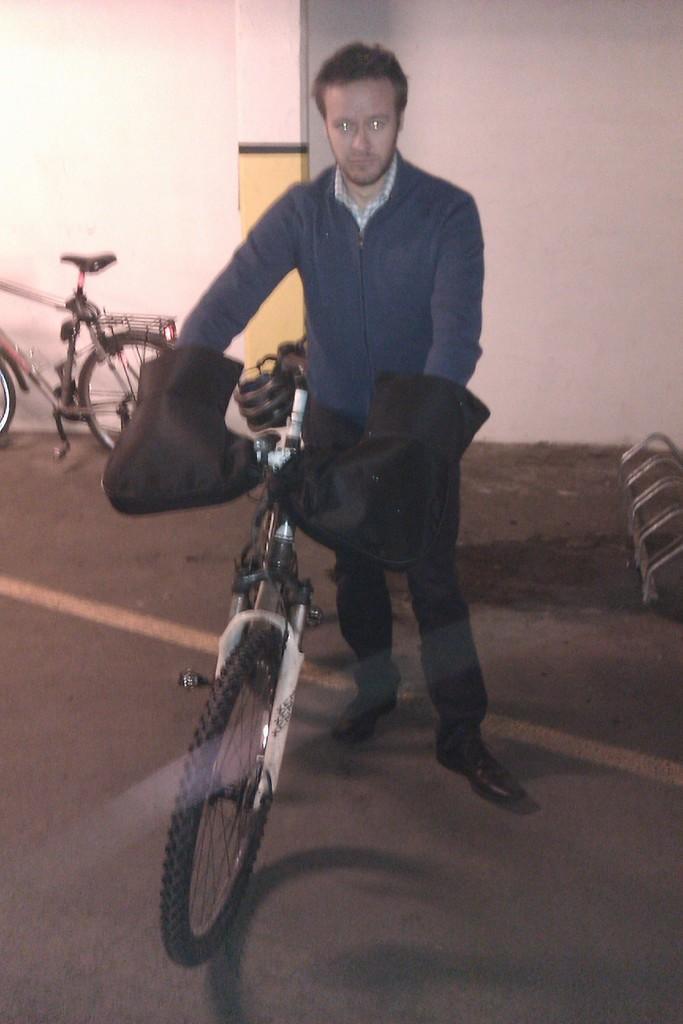How would you summarize this image in a sentence or two? In this image a man is standing. He is holding handles of a bicycle. In the left there is another bicycles. These are the stands. In the background there is white wall. 